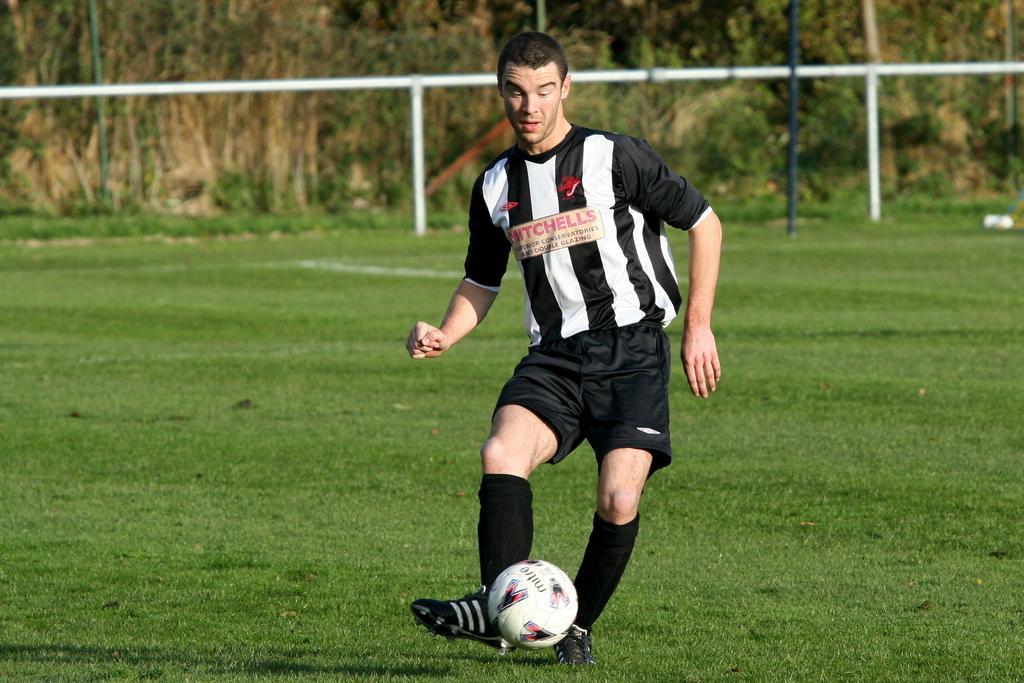In one or two sentences, can you explain what this image depicts? This picture is clicked in a ground. In the middle of this picture, we see a man wearing black and white T-shirt is playing football and the ball is white in color. Behind him, we see some iron rods and behind that, we see trees. 